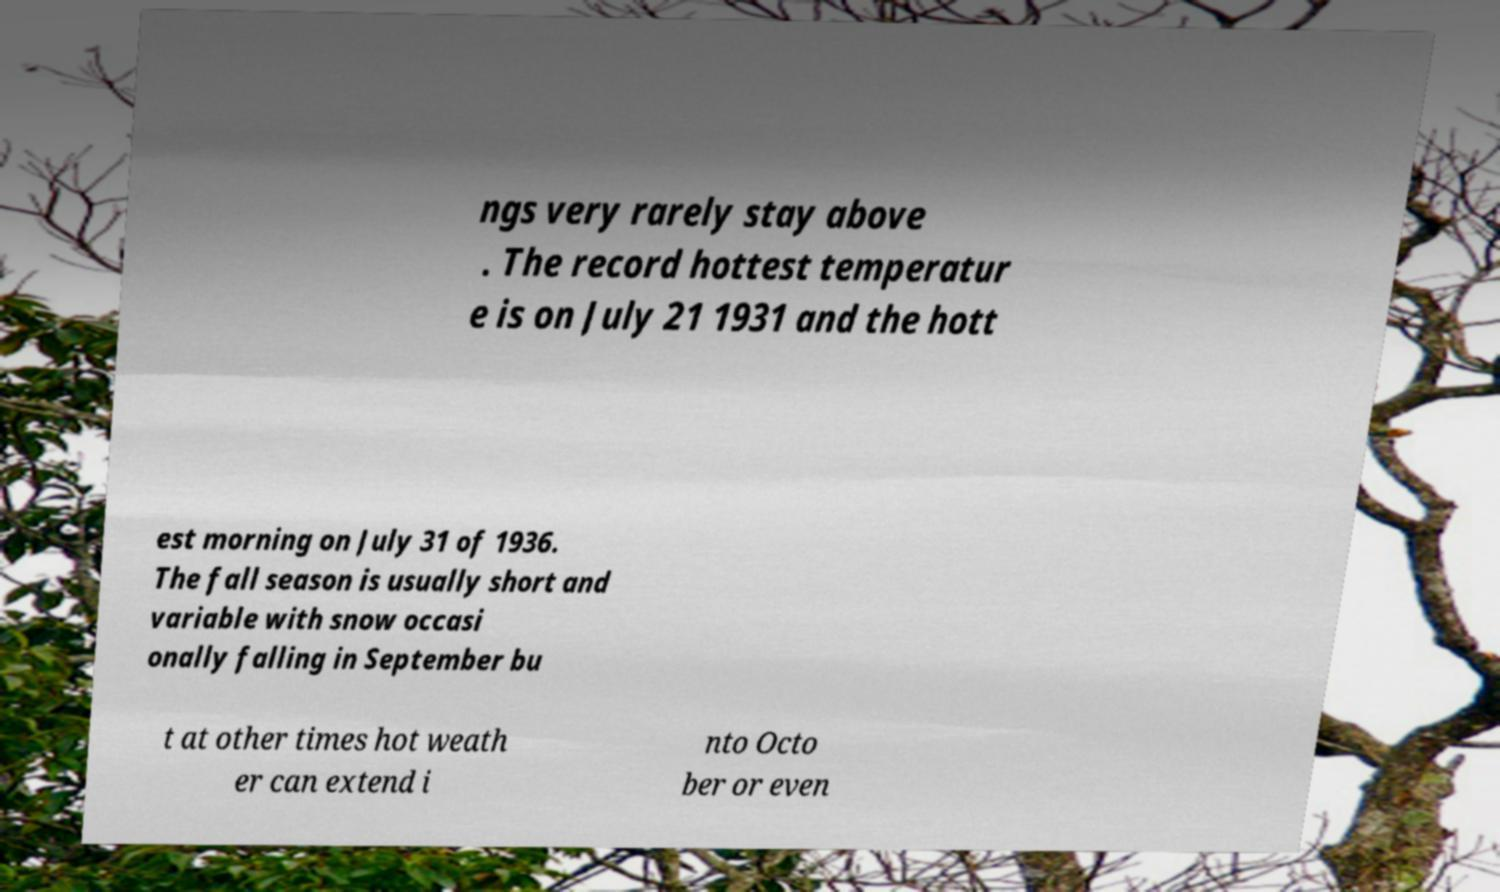Please read and relay the text visible in this image. What does it say? ngs very rarely stay above . The record hottest temperatur e is on July 21 1931 and the hott est morning on July 31 of 1936. The fall season is usually short and variable with snow occasi onally falling in September bu t at other times hot weath er can extend i nto Octo ber or even 